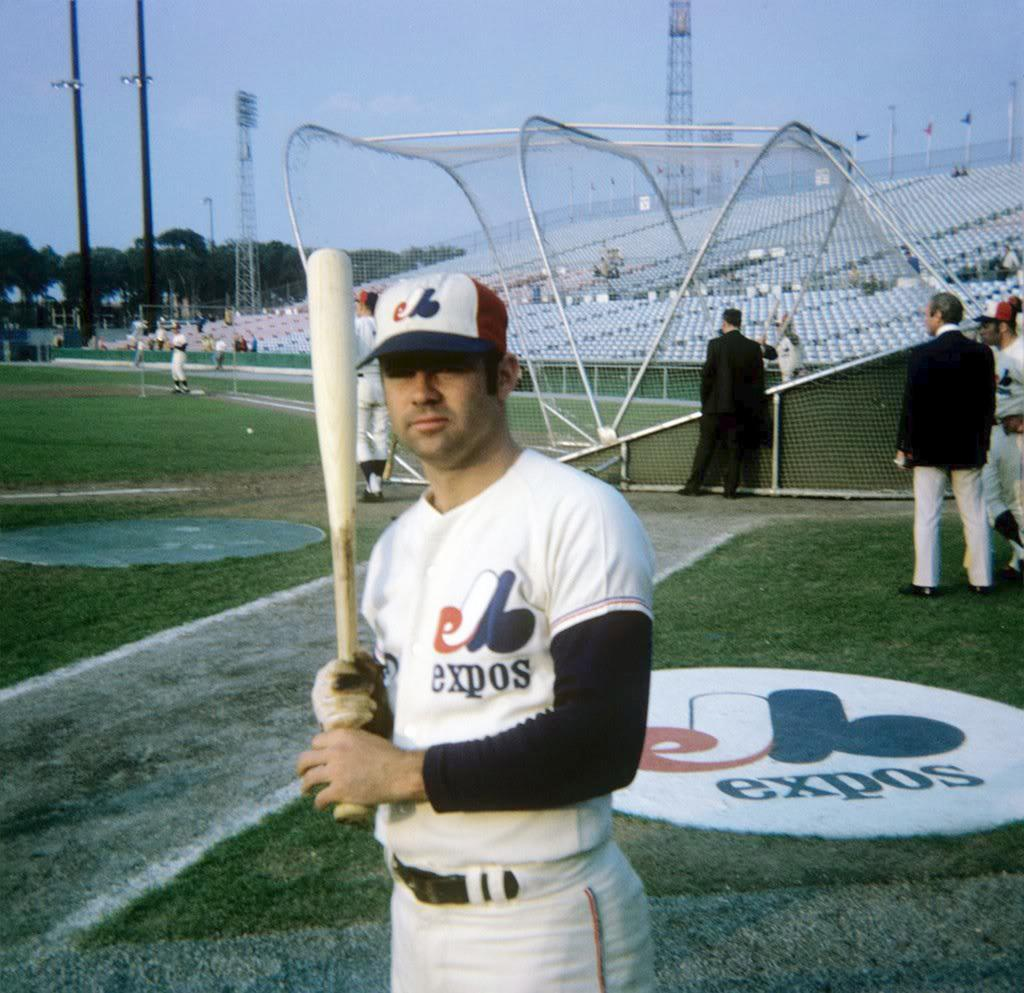Provide a one-sentence caption for the provided image. A baseball player with an Expos uniform poses with a bat on the side of the field. 